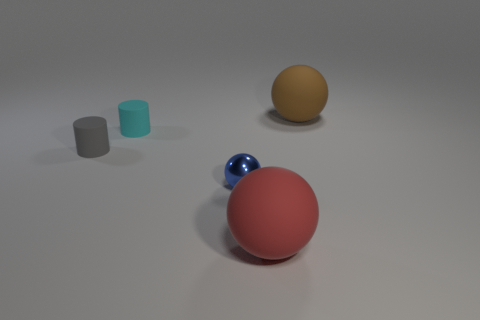Are there the same number of objects behind the small gray matte cylinder and large red objects on the right side of the brown sphere?
Your response must be concise. No. Are there more gray things that are right of the small cyan thing than small cyan matte objects?
Provide a short and direct response. No. What shape is the cyan object that is made of the same material as the gray cylinder?
Your answer should be compact. Cylinder. Does the shiny thing that is on the right side of the cyan matte thing have the same size as the small gray object?
Give a very brief answer. Yes. What shape is the big object that is in front of the matte thing right of the large red ball?
Ensure brevity in your answer.  Sphere. There is a matte sphere in front of the brown ball that is behind the big red matte ball; what size is it?
Provide a succinct answer. Large. There is a big sphere that is behind the small cyan rubber cylinder; what color is it?
Your response must be concise. Brown. There is a cyan cylinder that is made of the same material as the small gray cylinder; what is its size?
Your answer should be very brief. Small. What number of large brown matte things have the same shape as the cyan thing?
Provide a succinct answer. 0. What is the material of the blue object that is the same size as the gray matte object?
Keep it short and to the point. Metal. 